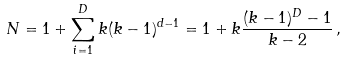<formula> <loc_0><loc_0><loc_500><loc_500>N = 1 + \sum _ { i = 1 } ^ { D } k ( k - 1 ) ^ { d - 1 } = 1 + k \frac { ( k - 1 ) ^ { D } - 1 } { k - 2 } \, ,</formula> 